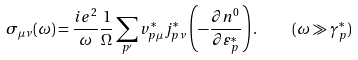<formula> <loc_0><loc_0><loc_500><loc_500>\sigma _ { \mu \nu } ( \omega ) = \frac { i e ^ { 2 } } { \omega } \frac { 1 } { \Omega } \sum _ { p ^ { \prime } } v ^ { * } _ { p \mu } j ^ { * } _ { p \nu } \left ( - \frac { \partial n ^ { 0 } } { \partial \varepsilon ^ { * } _ { p } } \right ) . \quad ( \omega \gg \gamma ^ { * } _ { p } )</formula> 